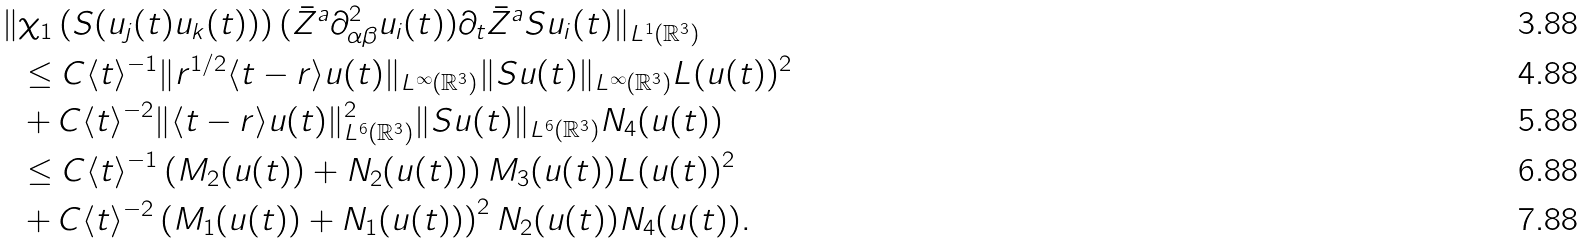Convert formula to latex. <formula><loc_0><loc_0><loc_500><loc_500>\| & \chi _ { 1 } \left ( S ( u _ { j } ( t ) u _ { k } ( t ) ) \right ) ( { \bar { Z } } ^ { a } \partial _ { \alpha \beta } ^ { 2 } u _ { i } ( t ) ) \partial _ { t } { \bar { Z } } ^ { a } S u _ { i } ( t ) \| _ { L ^ { 1 } ( { \mathbb { R } } ^ { 3 } ) } \\ & \leq C \langle t \rangle ^ { - 1 } \| r ^ { 1 / 2 } \langle t - r \rangle u ( t ) \| _ { L ^ { \infty } ( { \mathbb { R } } ^ { 3 } ) } \| S u ( t ) \| _ { L ^ { \infty } ( { \mathbb { R } } ^ { 3 } ) } L ( u ( t ) ) ^ { 2 } \\ & + C \langle t \rangle ^ { - 2 } \| \langle t - r \rangle u ( t ) \| _ { L ^ { 6 } ( { \mathbb { R } } ^ { 3 } ) } ^ { 2 } \| S u ( t ) \| _ { L ^ { 6 } ( { \mathbb { R } } ^ { 3 } ) } N _ { 4 } ( u ( t ) ) \\ & \leq C \langle t \rangle ^ { - 1 } \left ( M _ { 2 } ( u ( t ) ) + N _ { 2 } ( u ( t ) ) \right ) M _ { 3 } ( u ( t ) ) L ( u ( t ) ) ^ { 2 } \\ & + C \langle t \rangle ^ { - 2 } \left ( M _ { 1 } ( u ( t ) ) + N _ { 1 } ( u ( t ) ) \right ) ^ { 2 } N _ { 2 } ( u ( t ) ) N _ { 4 } ( u ( t ) ) .</formula> 